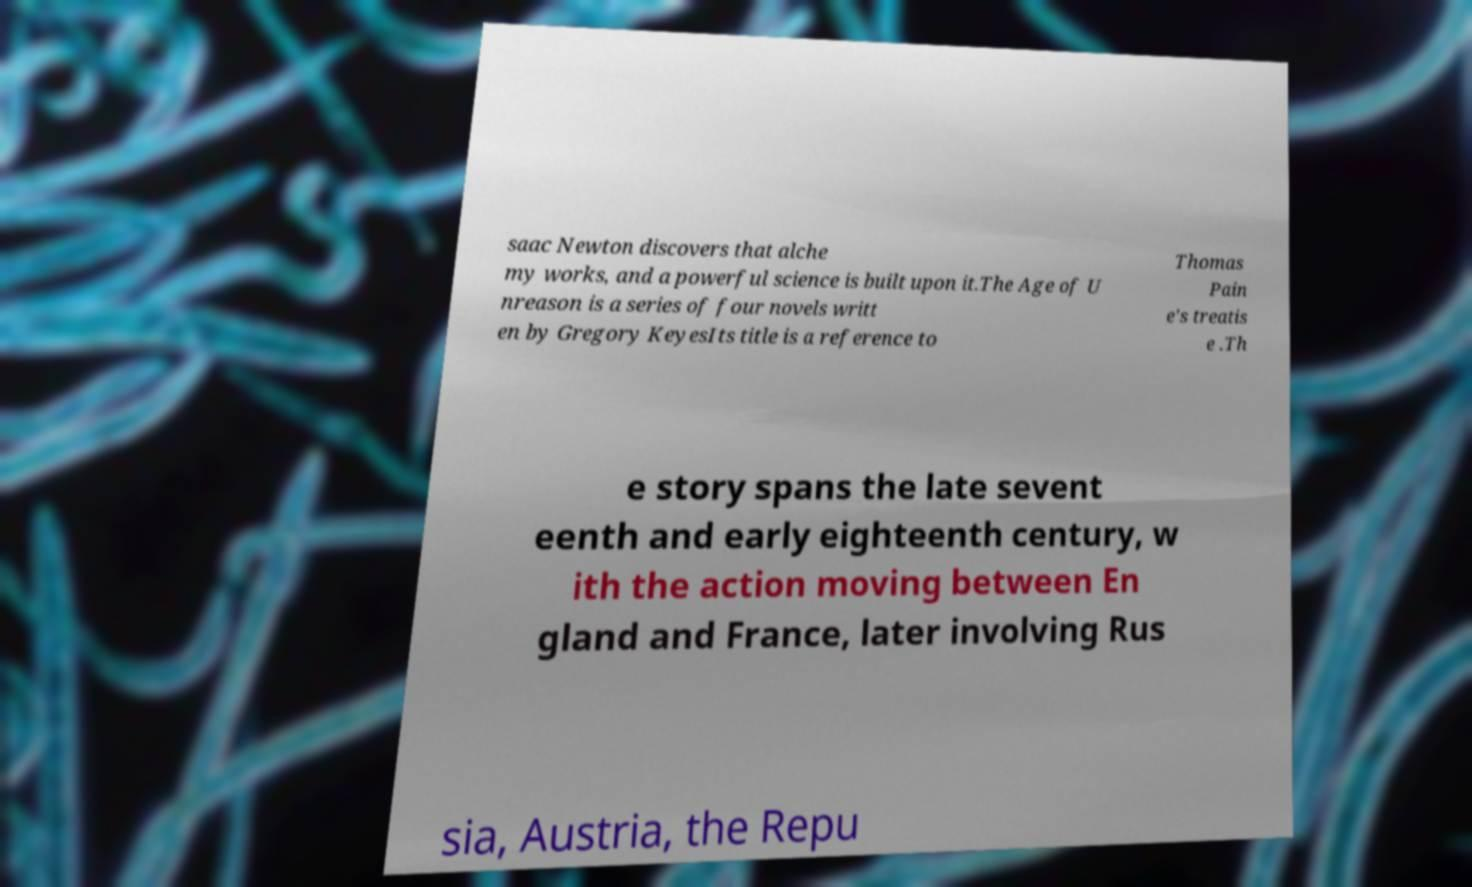There's text embedded in this image that I need extracted. Can you transcribe it verbatim? saac Newton discovers that alche my works, and a powerful science is built upon it.The Age of U nreason is a series of four novels writt en by Gregory KeyesIts title is a reference to Thomas Pain e's treatis e .Th e story spans the late sevent eenth and early eighteenth century, w ith the action moving between En gland and France, later involving Rus sia, Austria, the Repu 